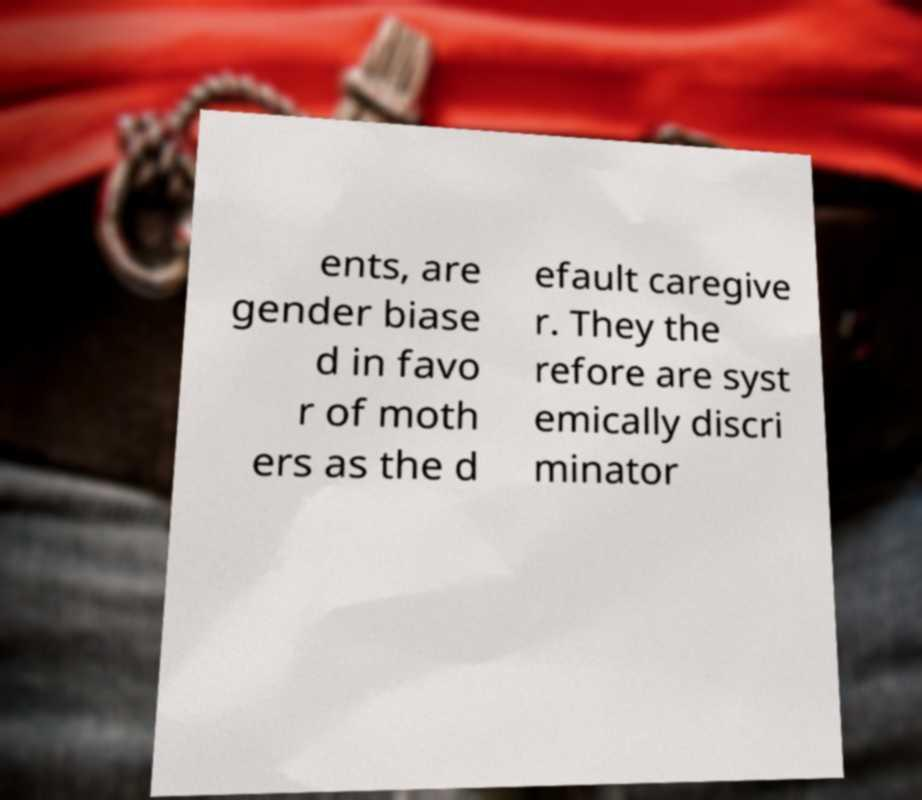For documentation purposes, I need the text within this image transcribed. Could you provide that? ents, are gender biase d in favo r of moth ers as the d efault caregive r. They the refore are syst emically discri minator 